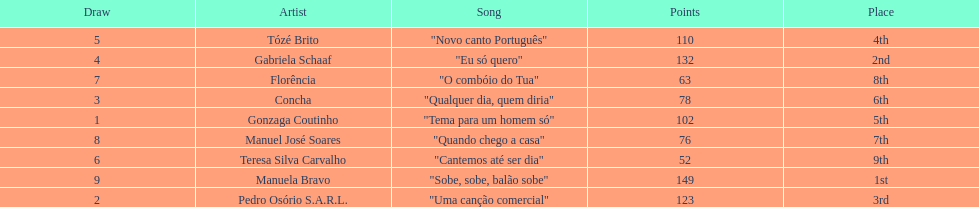Who scored the most points? Manuela Bravo. 